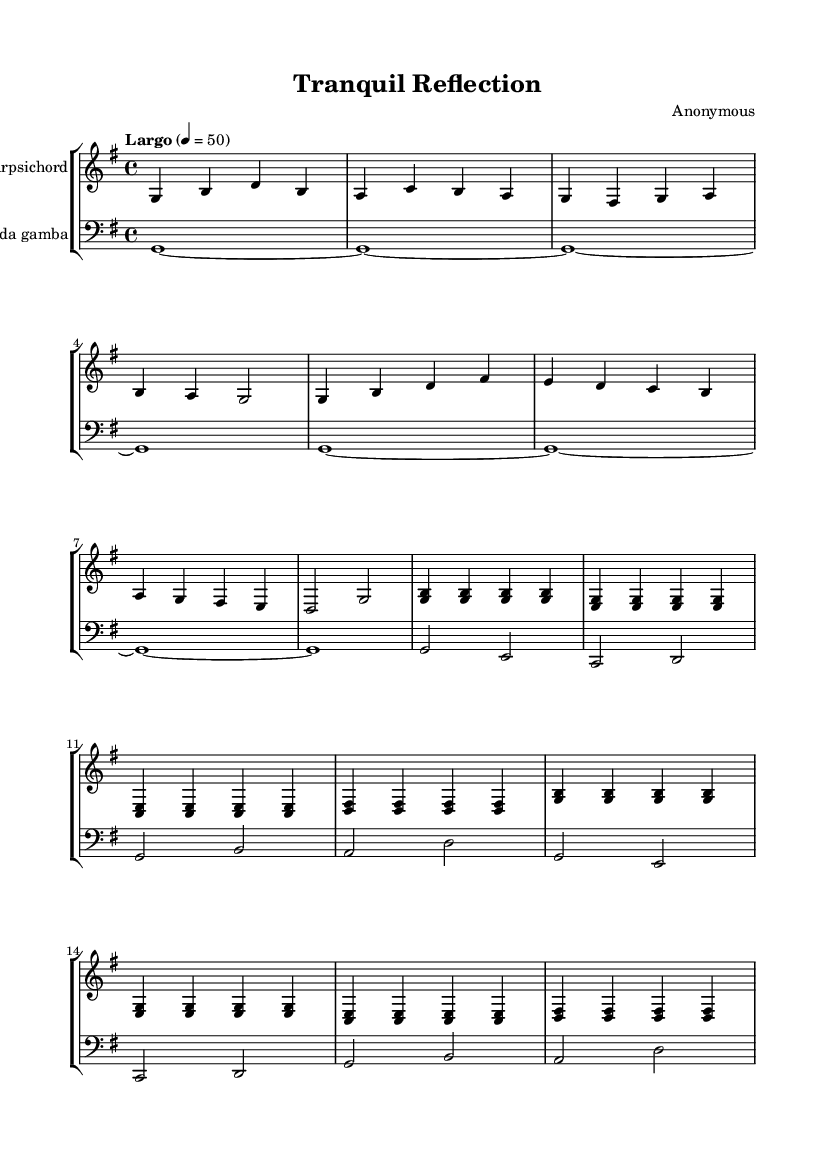What is the key signature of this music? The key signature indicated at the beginning of the score is G major, which has one sharp (F#).
Answer: G major What is the time signature of this composition? The time signature shown at the beginning is 4/4, meaning there are four beats in each measure, and the quarter note receives one beat.
Answer: 4/4 What tempo marking is given in the music? The tempo marking is Largo, which typically indicates a slow tempo, with a metronome marking of 50 beats per minute.
Answer: Largo How many measures are repeated in the harpsichord part? The harpsichord part has a repeat indication for two measures, specifically noted with "repeat unfold 2".
Answer: 2 What instruments are used in this composition? The score features a Harpsichord and a Viola da gamba, both indicated at the beginning of their respective staves.
Answer: Harpsichord, Viola da gamba Which characteristic makes this composition minimalistic in style? The repetitive patterns and sparse textures in both the harpsichord and viola da gamba parts emphasize simplicity and calm, which are key aspects of minimalism.
Answer: Repetitive patterns 